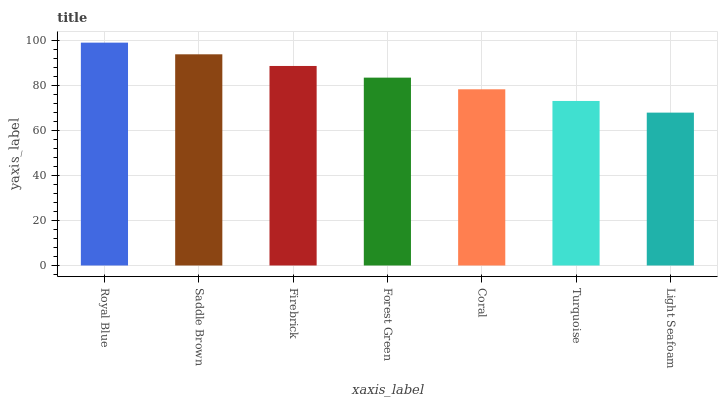Is Light Seafoam the minimum?
Answer yes or no. Yes. Is Royal Blue the maximum?
Answer yes or no. Yes. Is Saddle Brown the minimum?
Answer yes or no. No. Is Saddle Brown the maximum?
Answer yes or no. No. Is Royal Blue greater than Saddle Brown?
Answer yes or no. Yes. Is Saddle Brown less than Royal Blue?
Answer yes or no. Yes. Is Saddle Brown greater than Royal Blue?
Answer yes or no. No. Is Royal Blue less than Saddle Brown?
Answer yes or no. No. Is Forest Green the high median?
Answer yes or no. Yes. Is Forest Green the low median?
Answer yes or no. Yes. Is Saddle Brown the high median?
Answer yes or no. No. Is Coral the low median?
Answer yes or no. No. 